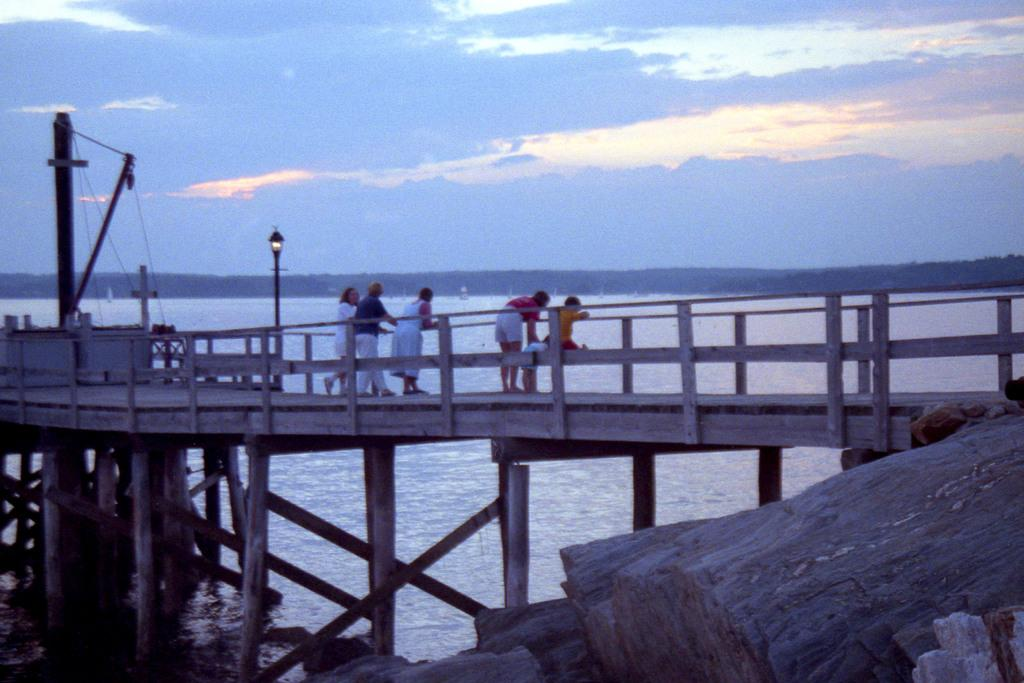What is the main structure in the image? There is a platform in the image. What is happening on the platform? There are people standing on the platform. What other objects can be seen in the image? There are poles, wires, and a light in the image. Is there any water visible in the image? Yes, there is water visible in the image. What can be seen in the background of the image? There are clouds and the sky visible in the background of the image. How many bears can be seen swimming in the water in the image? There are no bears visible in the image; it only features a platform, people, poles, wires, a light, water, clouds, and the sky. Is there a coast visible in the image? There is no coast visible in the image; it only features a platform, people, poles, wires, a light, water, clouds, and the sky. 